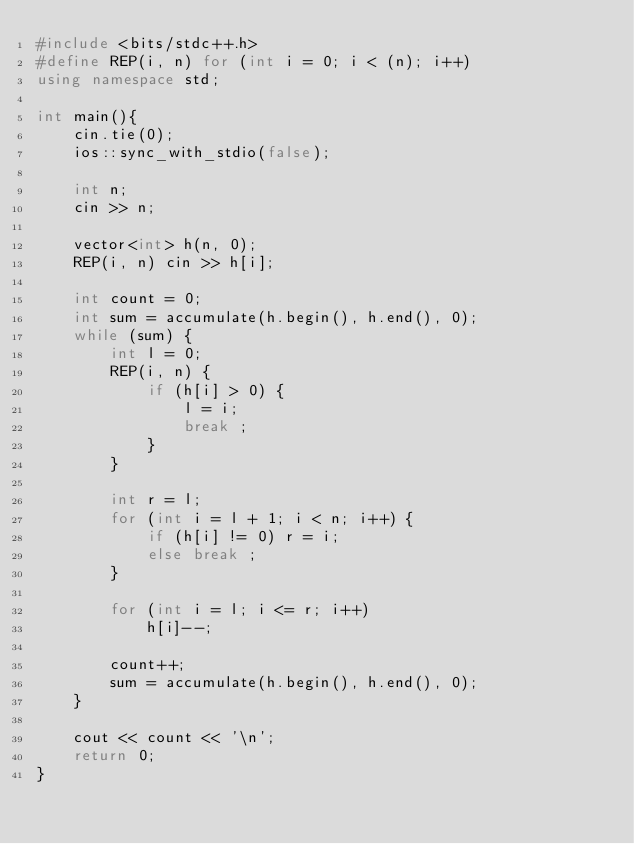<code> <loc_0><loc_0><loc_500><loc_500><_C++_>#include <bits/stdc++.h>
#define REP(i, n) for (int i = 0; i < (n); i++)
using namespace std;

int main(){
    cin.tie(0);
    ios::sync_with_stdio(false);

    int n;
    cin >> n;

    vector<int> h(n, 0);
    REP(i, n) cin >> h[i];

    int count = 0;
    int sum = accumulate(h.begin(), h.end(), 0);
    while (sum) {
        int l = 0;
        REP(i, n) {
            if (h[i] > 0) {
                l = i;
                break ;
            }
        }

        int r = l;
        for (int i = l + 1; i < n; i++) {
            if (h[i] != 0) r = i;
            else break ;
        }

        for (int i = l; i <= r; i++)
            h[i]--;

        count++;
        sum = accumulate(h.begin(), h.end(), 0);
    }

    cout << count << '\n';
    return 0;
}
</code> 